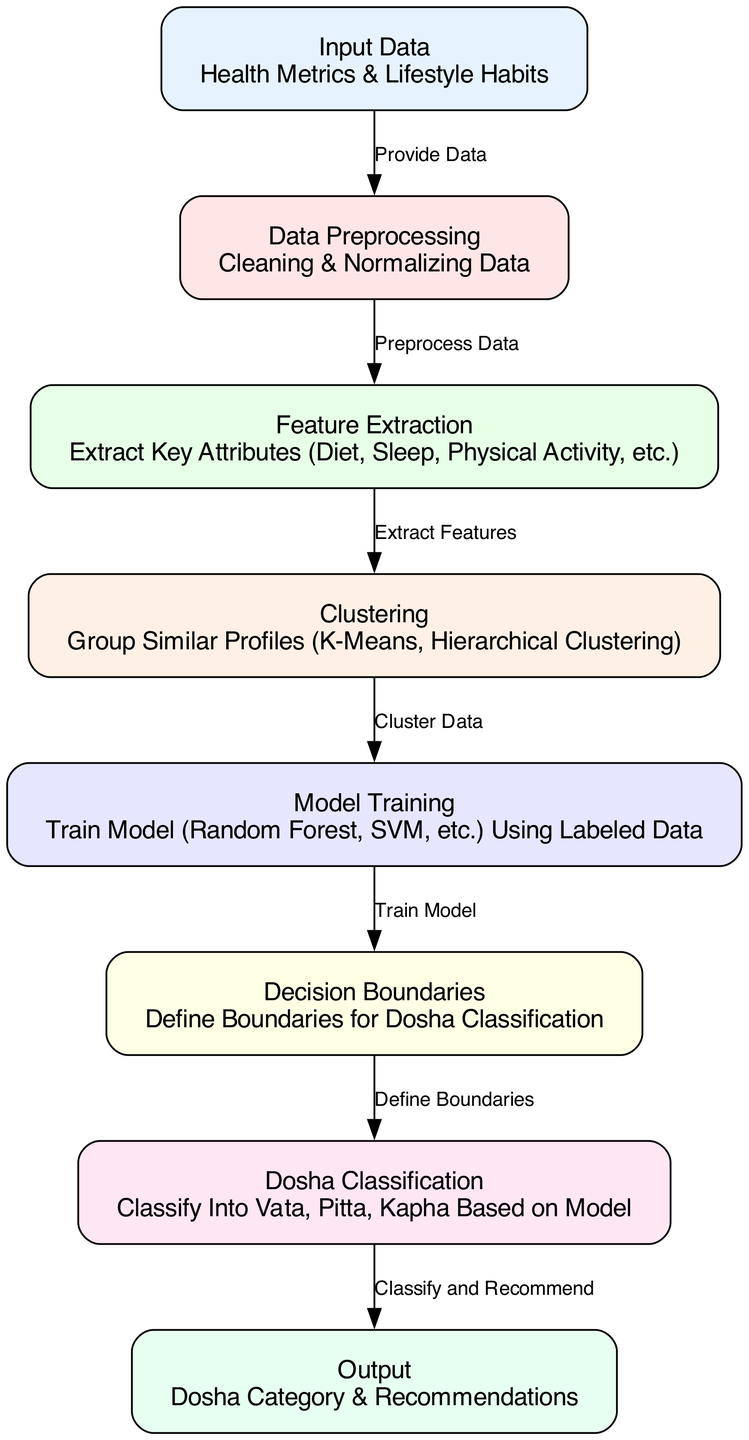What is the first node in the diagram? The first node in the diagram is labeled "Input Data" and represents the starting point where health metrics and lifestyle habits are provided.
Answer: Input Data How many nodes are in the diagram? By counting the individual nodes listed, there are a total of eight nodes in the diagram.
Answer: Eight What type of model is trained in the "Model Training" node? The "Model Training" node indicates that models such as Random Forest and SVM (Support Vector Machine) are used for training purposes.
Answer: Random Forest, SVM What is the output of the "Dosha Classification" node? The output of the "Dosha Classification" node is the classification of the individual into one of the doshas: Vata, Pitta, or Kapha, along with recommendations.
Answer: Dosha Category & Recommendations What is the relationship between the "Clustering" and "Model Training" nodes? The relationship is that the "Clustering" node provides the grouped data to the "Model Training" node, indicating that clustering data is essential for model training.
Answer: Cluster Data Which node executes data preprocessing? The node labeled "Data Preprocessing" is responsible for cleaning and normalizing the input data before further processing.
Answer: Data Preprocessing What is the purpose of the "Feature Extraction" node? The "Feature Extraction" node's purpose is to extract key attributes from the input data, such as diet, sleep, and physical activity, which are relevant for dosha classification.
Answer: Extract Key Attributes What informs the "Decision Boundaries" in the diagram? The "Decision Boundaries" are defined based on the trained model from the "Model Training" node, which indicates the separation of different dosha classes in the feature space.
Answer: Trained Model What process follows the "Feature Extraction" node? Following the "Feature Extraction" node, the next process is the "Clustering" where similar profiles are grouped based on the extracted features.
Answer: Clustering 